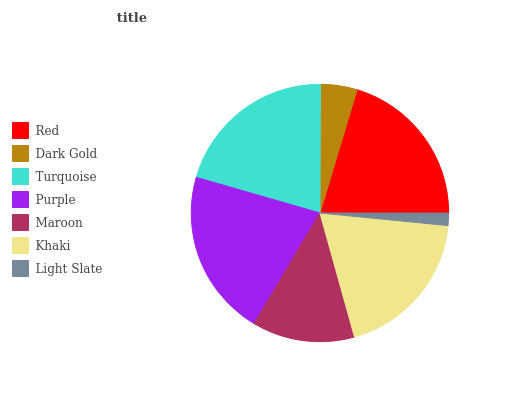Is Light Slate the minimum?
Answer yes or no. Yes. Is Purple the maximum?
Answer yes or no. Yes. Is Dark Gold the minimum?
Answer yes or no. No. Is Dark Gold the maximum?
Answer yes or no. No. Is Red greater than Dark Gold?
Answer yes or no. Yes. Is Dark Gold less than Red?
Answer yes or no. Yes. Is Dark Gold greater than Red?
Answer yes or no. No. Is Red less than Dark Gold?
Answer yes or no. No. Is Khaki the high median?
Answer yes or no. Yes. Is Khaki the low median?
Answer yes or no. Yes. Is Purple the high median?
Answer yes or no. No. Is Light Slate the low median?
Answer yes or no. No. 